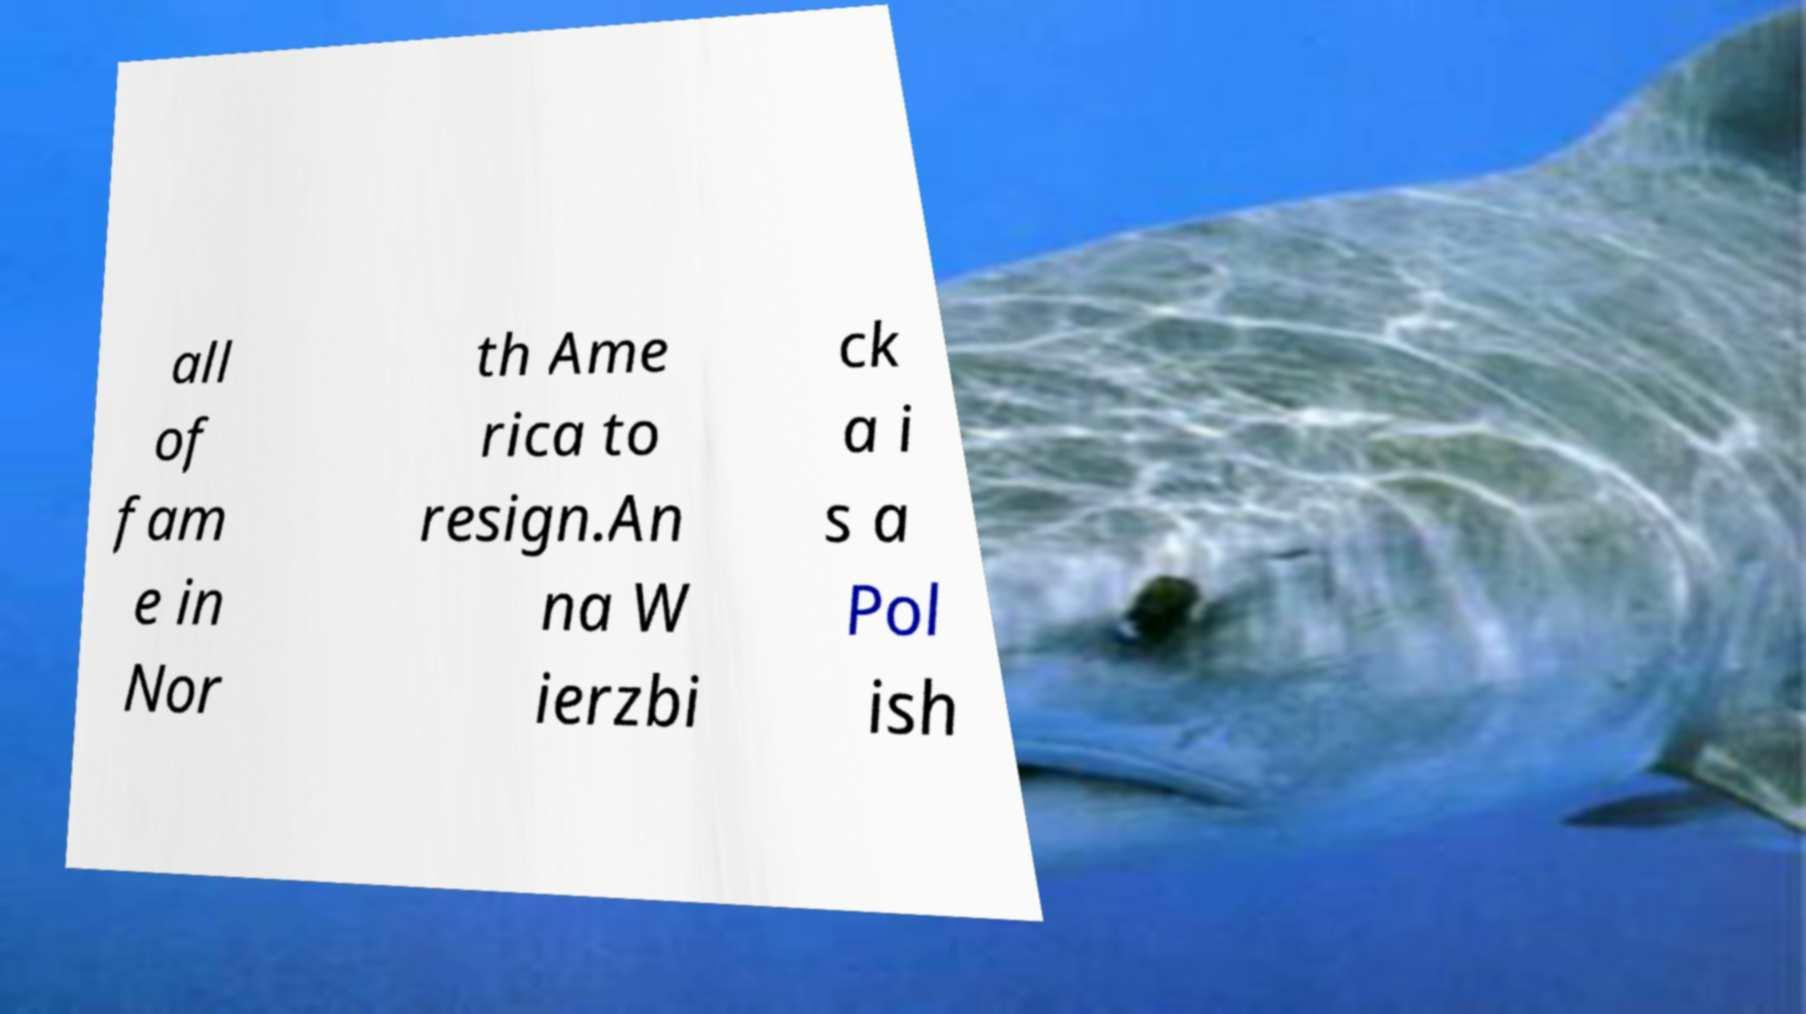Can you read and provide the text displayed in the image?This photo seems to have some interesting text. Can you extract and type it out for me? all of fam e in Nor th Ame rica to resign.An na W ierzbi ck a i s a Pol ish 